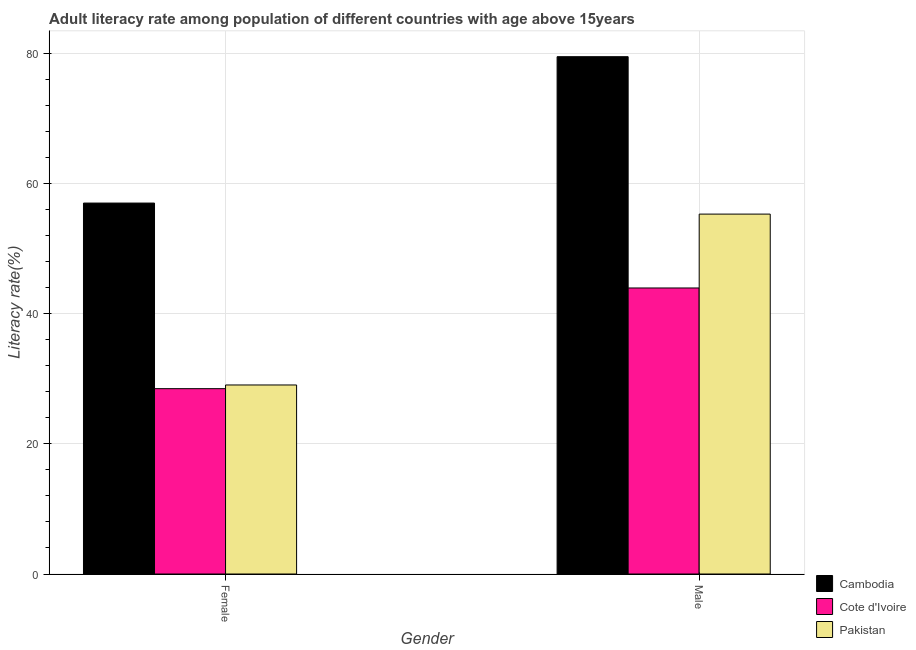How many groups of bars are there?
Offer a very short reply. 2. Are the number of bars on each tick of the X-axis equal?
Your answer should be compact. Yes. How many bars are there on the 2nd tick from the left?
Make the answer very short. 3. What is the male adult literacy rate in Cote d'Ivoire?
Make the answer very short. 43.95. Across all countries, what is the maximum female adult literacy rate?
Provide a succinct answer. 56.99. Across all countries, what is the minimum male adult literacy rate?
Your answer should be compact. 43.95. In which country was the female adult literacy rate maximum?
Provide a succinct answer. Cambodia. In which country was the female adult literacy rate minimum?
Offer a very short reply. Cote d'Ivoire. What is the total female adult literacy rate in the graph?
Offer a very short reply. 114.51. What is the difference between the female adult literacy rate in Cote d'Ivoire and that in Cambodia?
Provide a succinct answer. -28.52. What is the difference between the female adult literacy rate in Cambodia and the male adult literacy rate in Pakistan?
Keep it short and to the point. 1.7. What is the average male adult literacy rate per country?
Give a very brief answer. 59.58. What is the difference between the male adult literacy rate and female adult literacy rate in Pakistan?
Offer a very short reply. 26.25. In how many countries, is the female adult literacy rate greater than 68 %?
Give a very brief answer. 0. What is the ratio of the male adult literacy rate in Pakistan to that in Cote d'Ivoire?
Keep it short and to the point. 1.26. In how many countries, is the male adult literacy rate greater than the average male adult literacy rate taken over all countries?
Provide a short and direct response. 1. What does the 2nd bar from the left in Female represents?
Your answer should be compact. Cote d'Ivoire. What does the 1st bar from the right in Male represents?
Your response must be concise. Pakistan. Does the graph contain grids?
Your answer should be very brief. Yes. How are the legend labels stacked?
Your answer should be very brief. Vertical. What is the title of the graph?
Make the answer very short. Adult literacy rate among population of different countries with age above 15years. Does "Malaysia" appear as one of the legend labels in the graph?
Provide a short and direct response. No. What is the label or title of the X-axis?
Keep it short and to the point. Gender. What is the label or title of the Y-axis?
Make the answer very short. Literacy rate(%). What is the Literacy rate(%) in Cambodia in Female?
Ensure brevity in your answer.  56.99. What is the Literacy rate(%) in Cote d'Ivoire in Female?
Provide a succinct answer. 28.48. What is the Literacy rate(%) in Pakistan in Female?
Ensure brevity in your answer.  29.04. What is the Literacy rate(%) in Cambodia in Male?
Offer a terse response. 79.48. What is the Literacy rate(%) of Cote d'Ivoire in Male?
Give a very brief answer. 43.95. What is the Literacy rate(%) of Pakistan in Male?
Your answer should be compact. 55.3. Across all Gender, what is the maximum Literacy rate(%) in Cambodia?
Keep it short and to the point. 79.48. Across all Gender, what is the maximum Literacy rate(%) in Cote d'Ivoire?
Keep it short and to the point. 43.95. Across all Gender, what is the maximum Literacy rate(%) of Pakistan?
Make the answer very short. 55.3. Across all Gender, what is the minimum Literacy rate(%) in Cambodia?
Your answer should be compact. 56.99. Across all Gender, what is the minimum Literacy rate(%) in Cote d'Ivoire?
Your answer should be very brief. 28.48. Across all Gender, what is the minimum Literacy rate(%) of Pakistan?
Your answer should be very brief. 29.04. What is the total Literacy rate(%) in Cambodia in the graph?
Offer a very short reply. 136.47. What is the total Literacy rate(%) in Cote d'Ivoire in the graph?
Make the answer very short. 72.42. What is the total Literacy rate(%) in Pakistan in the graph?
Make the answer very short. 84.34. What is the difference between the Literacy rate(%) of Cambodia in Female and that in Male?
Provide a succinct answer. -22.49. What is the difference between the Literacy rate(%) in Cote d'Ivoire in Female and that in Male?
Make the answer very short. -15.47. What is the difference between the Literacy rate(%) in Pakistan in Female and that in Male?
Your response must be concise. -26.25. What is the difference between the Literacy rate(%) in Cambodia in Female and the Literacy rate(%) in Cote d'Ivoire in Male?
Provide a short and direct response. 13.05. What is the difference between the Literacy rate(%) of Cambodia in Female and the Literacy rate(%) of Pakistan in Male?
Your answer should be compact. 1.7. What is the difference between the Literacy rate(%) of Cote d'Ivoire in Female and the Literacy rate(%) of Pakistan in Male?
Provide a short and direct response. -26.82. What is the average Literacy rate(%) in Cambodia per Gender?
Offer a terse response. 68.24. What is the average Literacy rate(%) of Cote d'Ivoire per Gender?
Ensure brevity in your answer.  36.21. What is the average Literacy rate(%) in Pakistan per Gender?
Give a very brief answer. 42.17. What is the difference between the Literacy rate(%) of Cambodia and Literacy rate(%) of Cote d'Ivoire in Female?
Ensure brevity in your answer.  28.52. What is the difference between the Literacy rate(%) of Cambodia and Literacy rate(%) of Pakistan in Female?
Offer a very short reply. 27.95. What is the difference between the Literacy rate(%) of Cote d'Ivoire and Literacy rate(%) of Pakistan in Female?
Ensure brevity in your answer.  -0.57. What is the difference between the Literacy rate(%) of Cambodia and Literacy rate(%) of Cote d'Ivoire in Male?
Offer a terse response. 35.54. What is the difference between the Literacy rate(%) in Cambodia and Literacy rate(%) in Pakistan in Male?
Your response must be concise. 24.19. What is the difference between the Literacy rate(%) of Cote d'Ivoire and Literacy rate(%) of Pakistan in Male?
Offer a terse response. -11.35. What is the ratio of the Literacy rate(%) in Cambodia in Female to that in Male?
Make the answer very short. 0.72. What is the ratio of the Literacy rate(%) of Cote d'Ivoire in Female to that in Male?
Give a very brief answer. 0.65. What is the ratio of the Literacy rate(%) in Pakistan in Female to that in Male?
Your response must be concise. 0.53. What is the difference between the highest and the second highest Literacy rate(%) of Cambodia?
Provide a succinct answer. 22.49. What is the difference between the highest and the second highest Literacy rate(%) of Cote d'Ivoire?
Make the answer very short. 15.47. What is the difference between the highest and the second highest Literacy rate(%) of Pakistan?
Keep it short and to the point. 26.25. What is the difference between the highest and the lowest Literacy rate(%) in Cambodia?
Ensure brevity in your answer.  22.49. What is the difference between the highest and the lowest Literacy rate(%) in Cote d'Ivoire?
Your answer should be compact. 15.47. What is the difference between the highest and the lowest Literacy rate(%) in Pakistan?
Your answer should be compact. 26.25. 